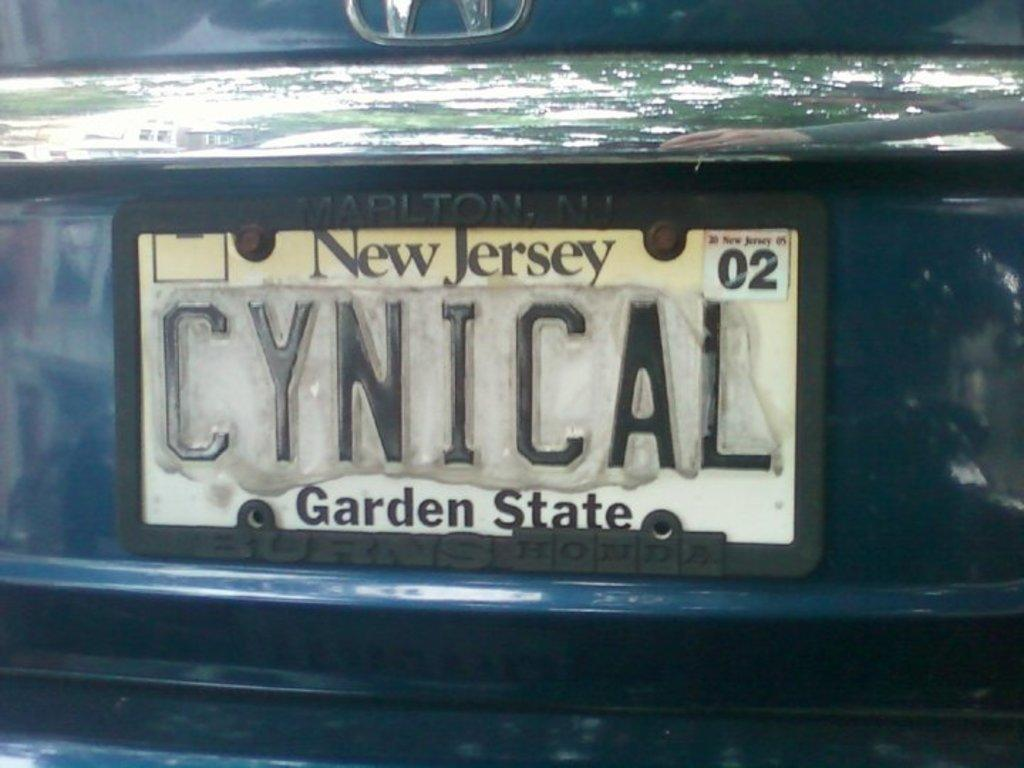<image>
Give a short and clear explanation of the subsequent image. the Garden State license plate that is on the back of a car 